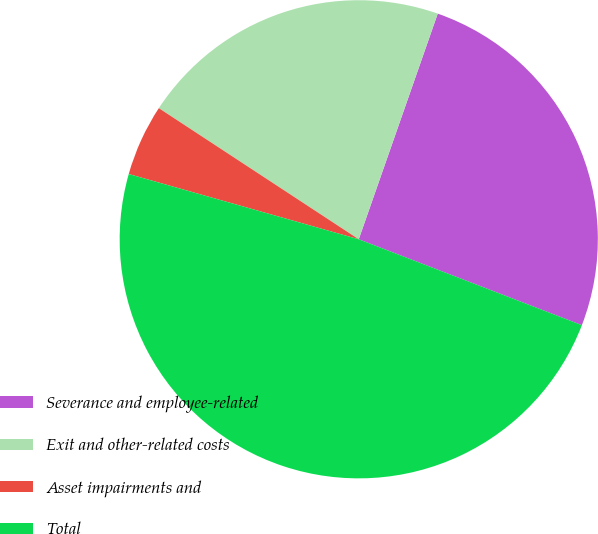<chart> <loc_0><loc_0><loc_500><loc_500><pie_chart><fcel>Severance and employee-related<fcel>Exit and other-related costs<fcel>Asset impairments and<fcel>Total<nl><fcel>25.49%<fcel>21.12%<fcel>4.84%<fcel>48.55%<nl></chart> 